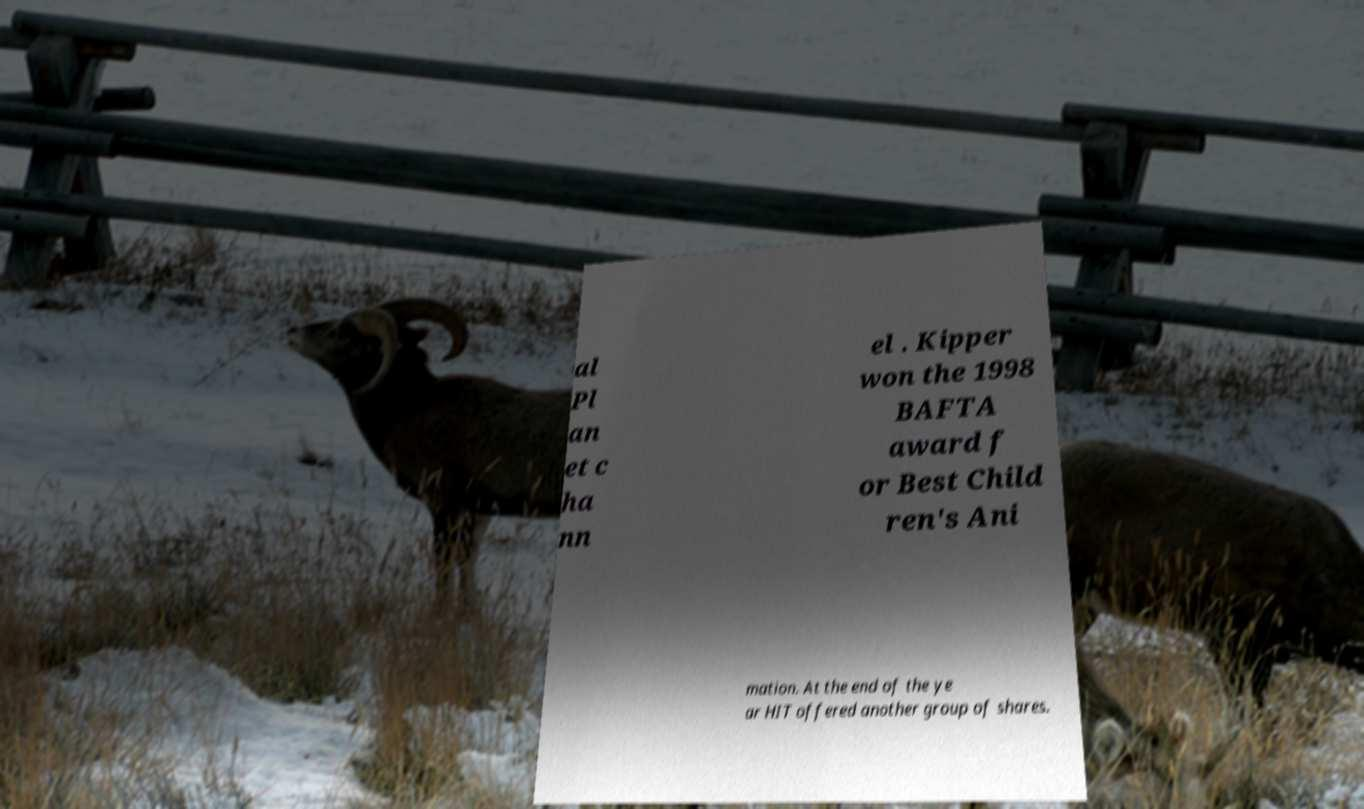There's text embedded in this image that I need extracted. Can you transcribe it verbatim? al Pl an et c ha nn el . Kipper won the 1998 BAFTA award f or Best Child ren's Ani mation. At the end of the ye ar HIT offered another group of shares. 